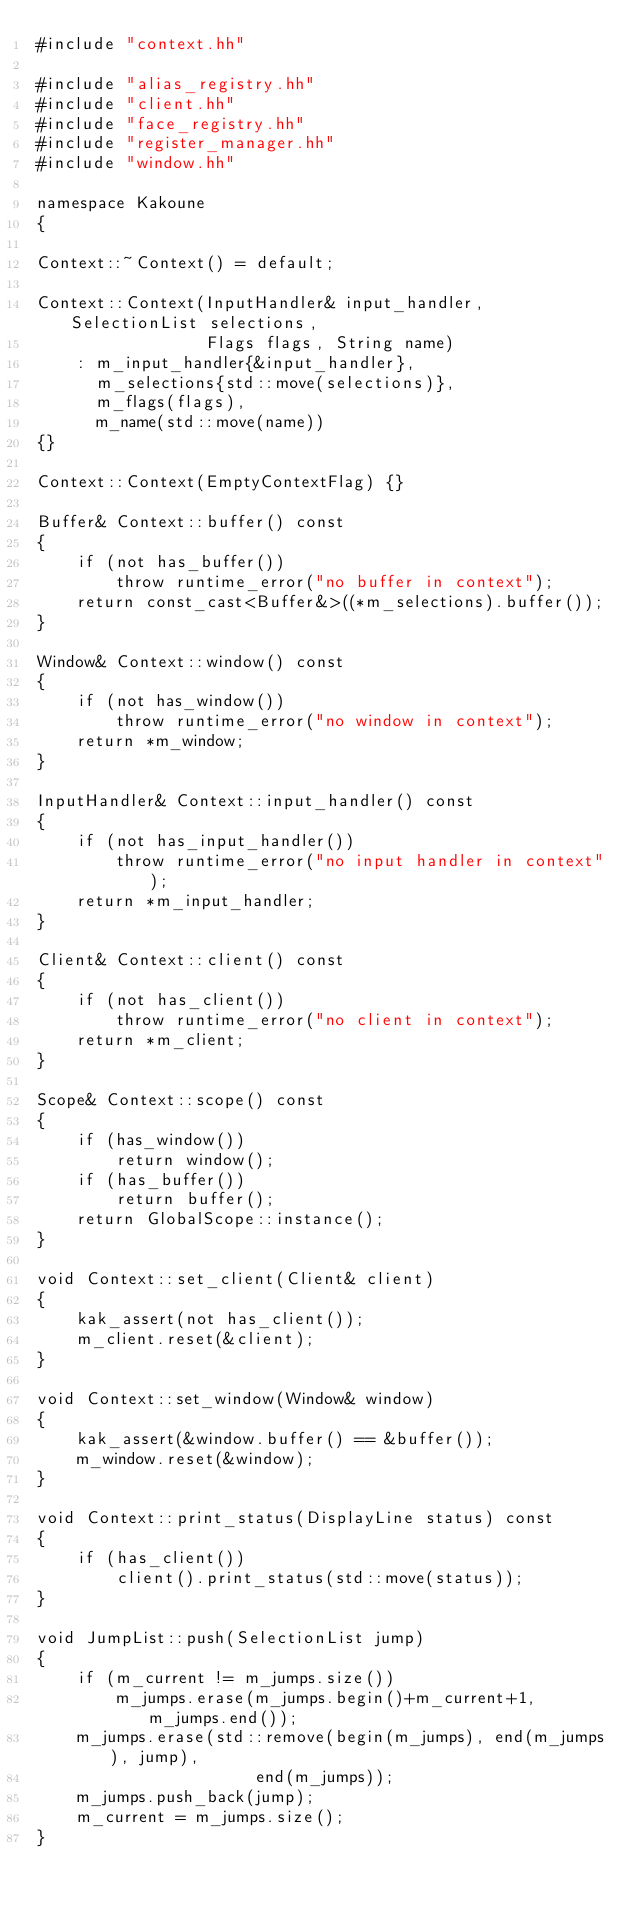Convert code to text. <code><loc_0><loc_0><loc_500><loc_500><_C++_>#include "context.hh"

#include "alias_registry.hh"
#include "client.hh"
#include "face_registry.hh"
#include "register_manager.hh"
#include "window.hh"

namespace Kakoune
{

Context::~Context() = default;

Context::Context(InputHandler& input_handler, SelectionList selections,
                 Flags flags, String name)
    : m_input_handler{&input_handler},
      m_selections{std::move(selections)},
      m_flags(flags),
      m_name(std::move(name))
{}

Context::Context(EmptyContextFlag) {}

Buffer& Context::buffer() const
{
    if (not has_buffer())
        throw runtime_error("no buffer in context");
    return const_cast<Buffer&>((*m_selections).buffer());
}

Window& Context::window() const
{
    if (not has_window())
        throw runtime_error("no window in context");
    return *m_window;
}

InputHandler& Context::input_handler() const
{
    if (not has_input_handler())
        throw runtime_error("no input handler in context");
    return *m_input_handler;
}

Client& Context::client() const
{
    if (not has_client())
        throw runtime_error("no client in context");
    return *m_client;
}

Scope& Context::scope() const
{
    if (has_window())
        return window();
    if (has_buffer())
        return buffer();
    return GlobalScope::instance();
}

void Context::set_client(Client& client)
{
    kak_assert(not has_client());
    m_client.reset(&client);
}

void Context::set_window(Window& window)
{
    kak_assert(&window.buffer() == &buffer());
    m_window.reset(&window);
}

void Context::print_status(DisplayLine status) const
{
    if (has_client())
        client().print_status(std::move(status));
}

void JumpList::push(SelectionList jump)
{
    if (m_current != m_jumps.size())
        m_jumps.erase(m_jumps.begin()+m_current+1, m_jumps.end());
    m_jumps.erase(std::remove(begin(m_jumps), end(m_jumps), jump),
                      end(m_jumps));
    m_jumps.push_back(jump);
    m_current = m_jumps.size();
}
</code> 